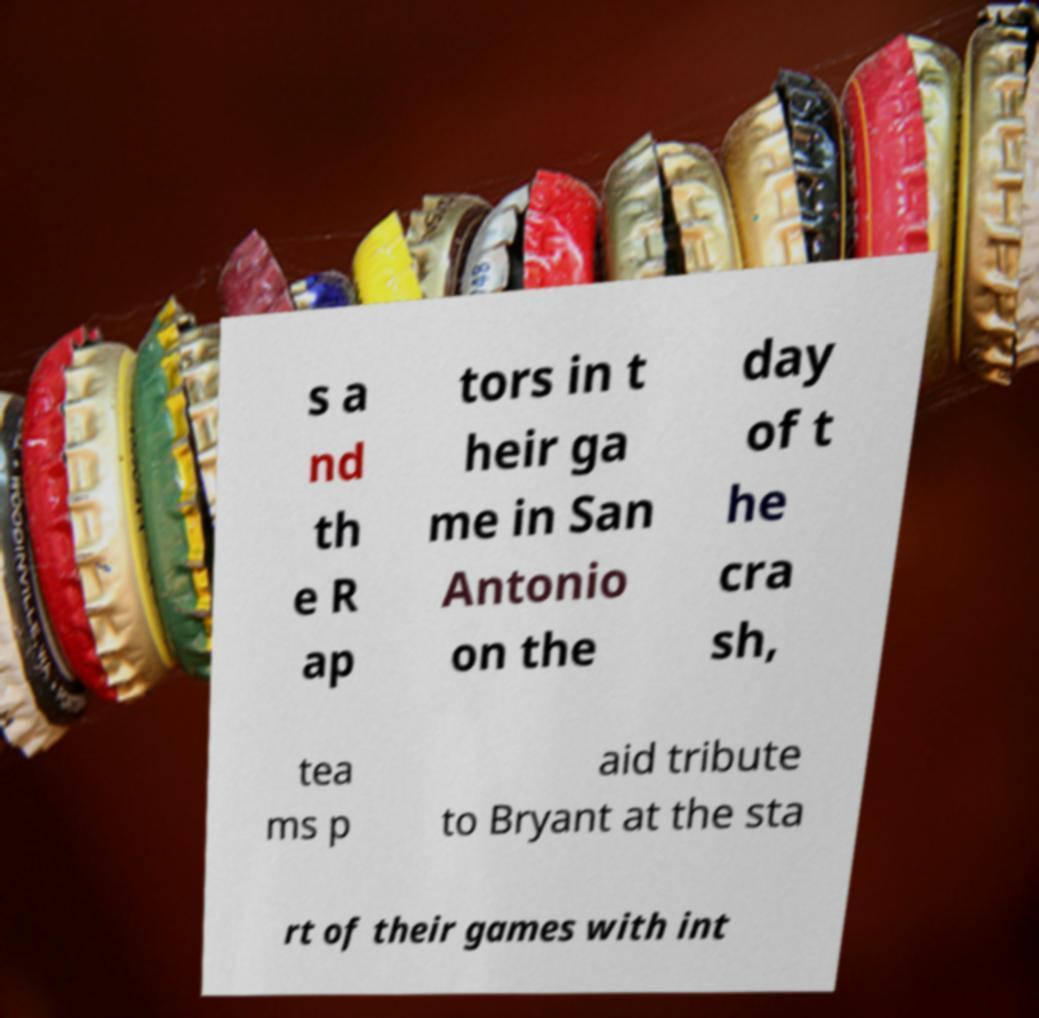There's text embedded in this image that I need extracted. Can you transcribe it verbatim? s a nd th e R ap tors in t heir ga me in San Antonio on the day of t he cra sh, tea ms p aid tribute to Bryant at the sta rt of their games with int 